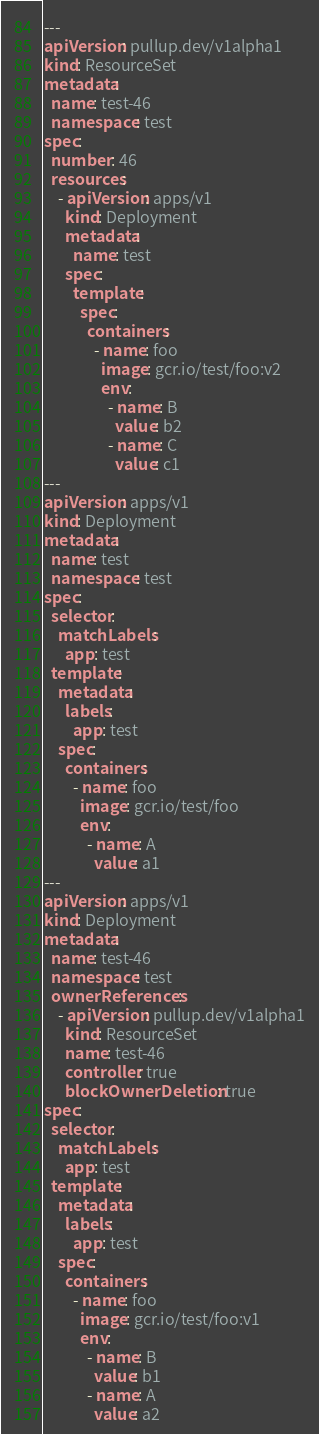<code> <loc_0><loc_0><loc_500><loc_500><_YAML_>---
apiVersion: pullup.dev/v1alpha1
kind: ResourceSet
metadata:
  name: test-46
  namespace: test
spec:
  number: 46
  resources:
    - apiVersion: apps/v1
      kind: Deployment
      metadata:
        name: test
      spec:
        template:
          spec:
            containers:
              - name: foo
                image: gcr.io/test/foo:v2
                env:
                  - name: B
                    value: b2
                  - name: C
                    value: c1
---
apiVersion: apps/v1
kind: Deployment
metadata:
  name: test
  namespace: test
spec:
  selector:
    matchLabels:
      app: test
  template:
    metadata:
      labels:
        app: test
    spec:
      containers:
        - name: foo
          image: gcr.io/test/foo
          env:
            - name: A
              value: a1
---
apiVersion: apps/v1
kind: Deployment
metadata:
  name: test-46
  namespace: test
  ownerReferences:
    - apiVersion: pullup.dev/v1alpha1
      kind: ResourceSet
      name: test-46
      controller: true
      blockOwnerDeletion: true
spec:
  selector:
    matchLabels:
      app: test
  template:
    metadata:
      labels:
        app: test
    spec:
      containers:
        - name: foo
          image: gcr.io/test/foo:v1
          env:
            - name: B
              value: b1
            - name: A
              value: a2
</code> 